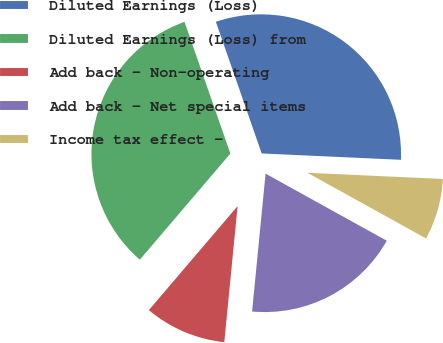<chart> <loc_0><loc_0><loc_500><loc_500><pie_chart><fcel>Diluted Earnings (Loss)<fcel>Diluted Earnings (Loss) from<fcel>Add back - Non-operating<fcel>Add back - Net special items<fcel>Income tax effect -<nl><fcel>31.06%<fcel>33.43%<fcel>9.69%<fcel>18.51%<fcel>7.32%<nl></chart> 